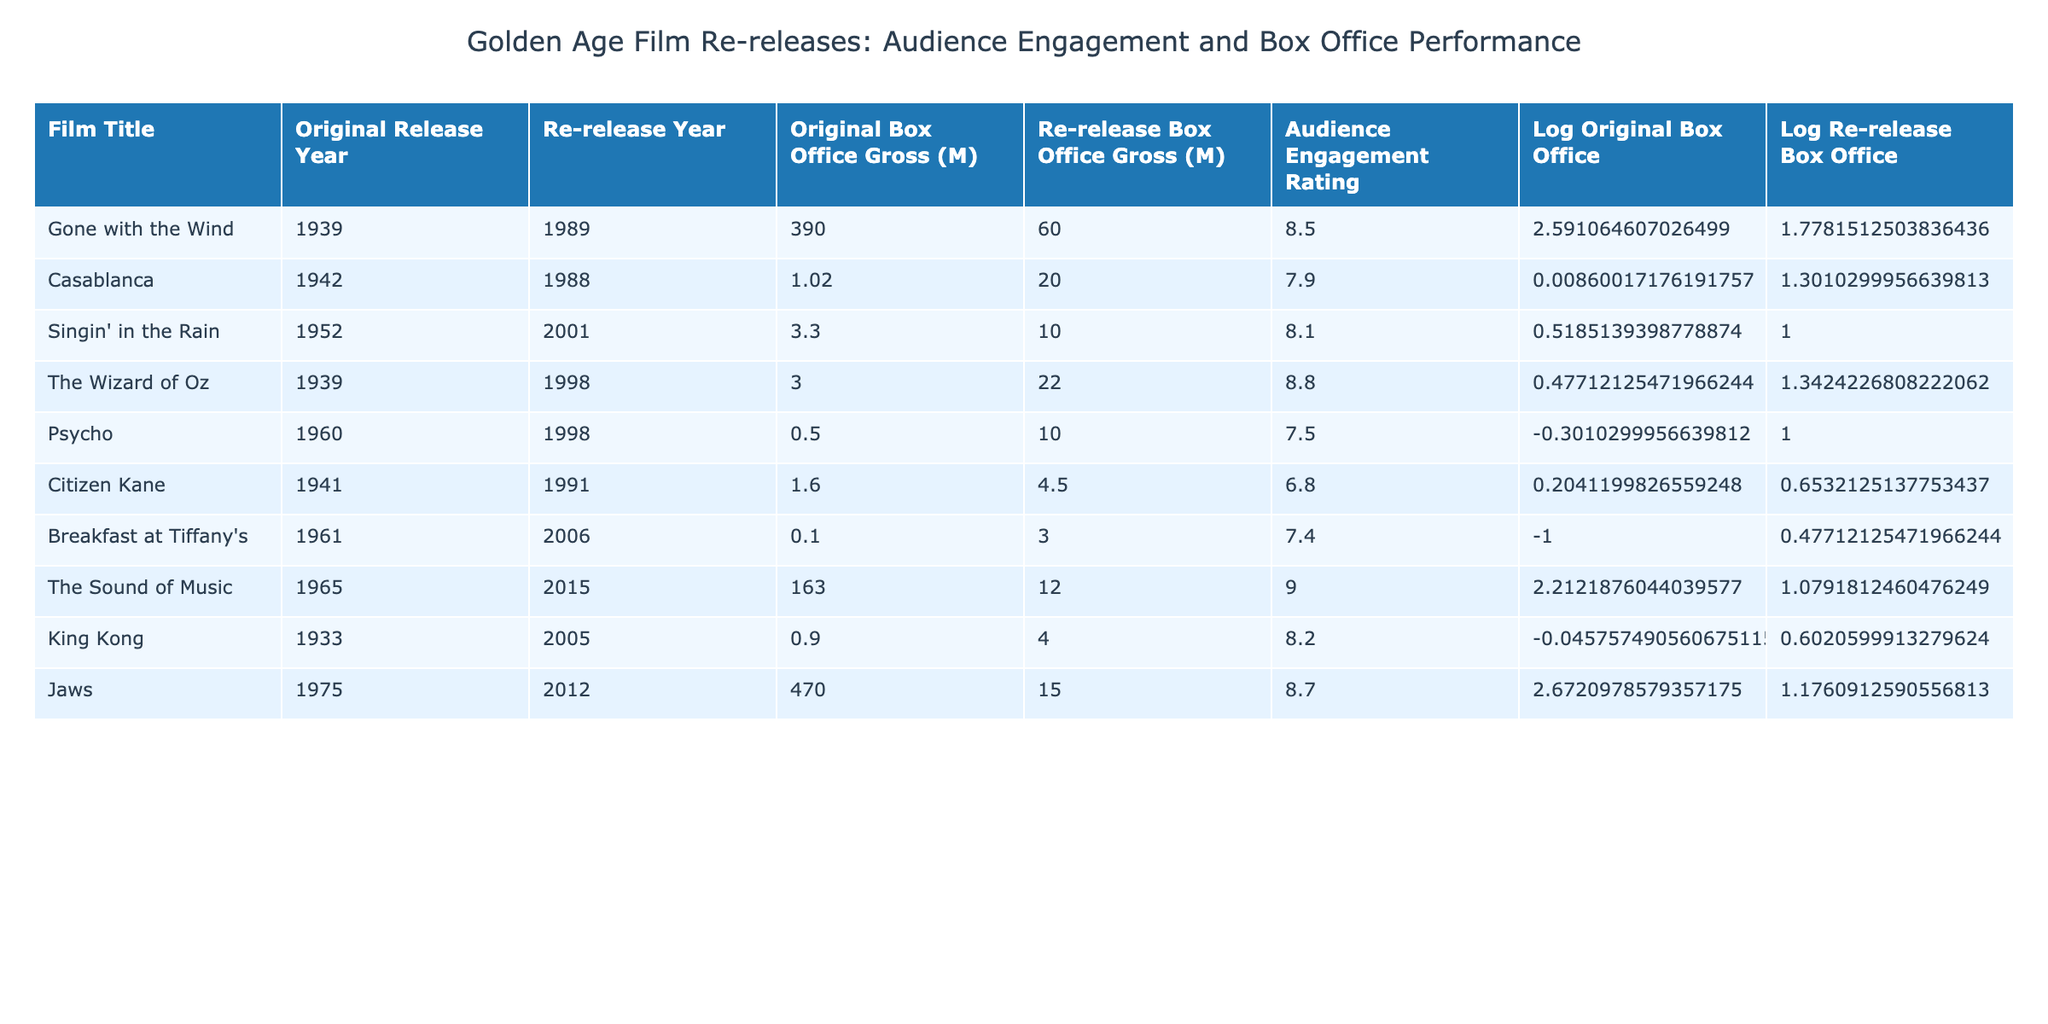What is the audience engagement rating for "The Wizard of Oz"? The table shows "The Wizard of Oz" with an audience engagement rating of 8.8.
Answer: 8.8 Which film re-release had the highest box office gross in its re-release? By comparing the Re-release Box Office Gross values, "Gone with the Wind" had the highest at 60 million.
Answer: Gone with the Wind What is the difference in audience engagement ratings between "Psycho" and "Gone with the Wind"? The audience engagement rating for "Psycho" is 7.5, and for "Gone with the Wind" it is 8.5. The difference is 8.5 - 7.5 = 1.0.
Answer: 1.0 Is the original box office gross for "Jaws" greater than that for "The Sound of Music"? "Jaws" has an original box office gross of 470 million, while "The Sound of Music" has 163 million. Since 470 is greater than 163, the statement is true.
Answer: Yes What is the average audience engagement rating of the films released in 2001? Only "Singin' in the Rain", released in 2001, has a rating of 8.1. Since there is only one film, the average is simply that rating: 8.1.
Answer: 8.1 Which film, originally released in the 1940s, had the lowest audience engagement rating? Among the films from the 1940s, "Citizen Kane" (6.8) and "Casablanca" (7.9) are the options. "Citizen Kane" has the lowest engagement rating of 6.8.
Answer: Citizen Kane What is the total original box office gross for all films released prior to 1960? Summing the original box office grosses for films released before 1960: "Gone with the Wind" (390) + "Casablanca" (1.02) + "Citizen Kane" (1.6) + "Singin' in the Rain" (3.3) + "Psycho" (0.5) + "Breakfast at Tiffany's" (0.1) + "The Wizard of Oz" (3.0) + "King Kong" (0.9) gives 400.42 million.
Answer: 400.42 million How many films had audience engagement ratings greater than 8.5? The films with audience engagement ratings above 8.5 are "The Wizard of Oz" (8.8) and "The Sound of Music" (9.0), totaling two films.
Answer: 2 Which film from the 1960s has the highest audience engagement rating? From the 1960s, "The Sound of Music" (9.0) and "Psycho" (7.5) are the films. "The Sound of Music" has the higher engagement rating at 9.0.
Answer: The Sound of Music 